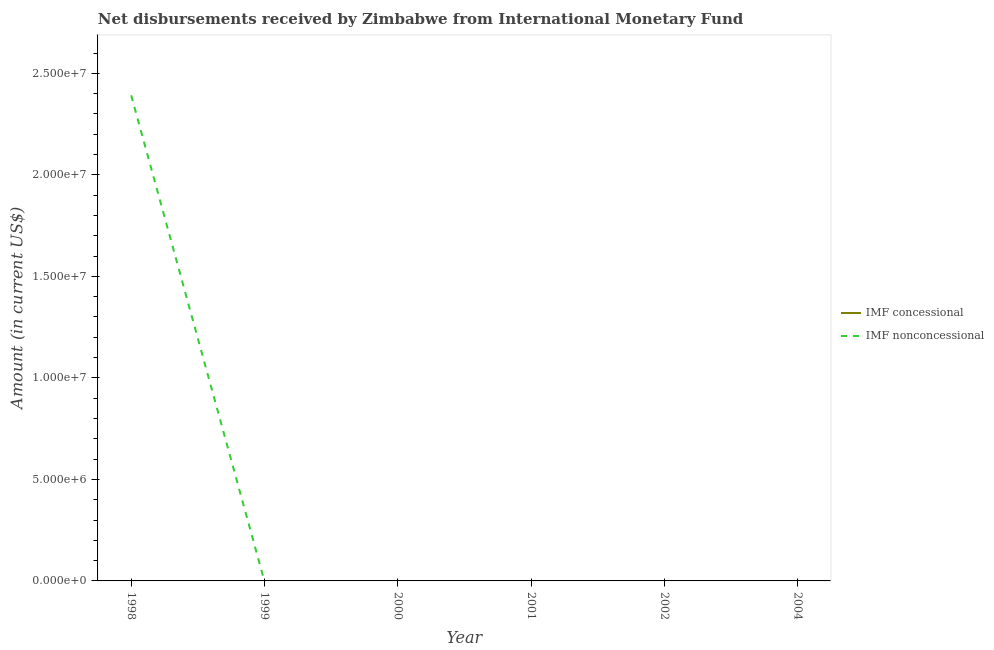Does the line corresponding to net non concessional disbursements from imf intersect with the line corresponding to net concessional disbursements from imf?
Offer a terse response. Yes. Is the number of lines equal to the number of legend labels?
Keep it short and to the point. No. Across all years, what is the maximum net non concessional disbursements from imf?
Provide a short and direct response. 2.39e+07. What is the total net non concessional disbursements from imf in the graph?
Your answer should be very brief. 2.39e+07. What is the difference between the net non concessional disbursements from imf in 1998 and the net concessional disbursements from imf in 1999?
Keep it short and to the point. 2.39e+07. In how many years, is the net concessional disbursements from imf greater than 7000000 US$?
Give a very brief answer. 0. What is the difference between the highest and the lowest net non concessional disbursements from imf?
Give a very brief answer. 2.39e+07. Does the net non concessional disbursements from imf monotonically increase over the years?
Offer a terse response. No. How many years are there in the graph?
Offer a terse response. 6. What is the difference between two consecutive major ticks on the Y-axis?
Your answer should be very brief. 5.00e+06. Are the values on the major ticks of Y-axis written in scientific E-notation?
Give a very brief answer. Yes. Does the graph contain any zero values?
Your response must be concise. Yes. Where does the legend appear in the graph?
Offer a terse response. Center right. What is the title of the graph?
Your response must be concise. Net disbursements received by Zimbabwe from International Monetary Fund. Does "Age 15+" appear as one of the legend labels in the graph?
Your answer should be very brief. No. What is the label or title of the X-axis?
Make the answer very short. Year. What is the Amount (in current US$) in IMF nonconcessional in 1998?
Ensure brevity in your answer.  2.39e+07. What is the Amount (in current US$) of IMF concessional in 1999?
Keep it short and to the point. 0. What is the Amount (in current US$) in IMF nonconcessional in 1999?
Your answer should be very brief. 0. What is the Amount (in current US$) in IMF concessional in 2000?
Make the answer very short. 0. What is the Amount (in current US$) of IMF nonconcessional in 2000?
Your answer should be very brief. 0. What is the Amount (in current US$) of IMF concessional in 2001?
Provide a short and direct response. 0. What is the Amount (in current US$) of IMF concessional in 2002?
Provide a short and direct response. 0. What is the Amount (in current US$) in IMF nonconcessional in 2002?
Make the answer very short. 0. What is the Amount (in current US$) in IMF concessional in 2004?
Provide a short and direct response. 0. Across all years, what is the maximum Amount (in current US$) in IMF nonconcessional?
Your response must be concise. 2.39e+07. Across all years, what is the minimum Amount (in current US$) of IMF nonconcessional?
Ensure brevity in your answer.  0. What is the total Amount (in current US$) in IMF concessional in the graph?
Provide a succinct answer. 0. What is the total Amount (in current US$) in IMF nonconcessional in the graph?
Make the answer very short. 2.39e+07. What is the average Amount (in current US$) in IMF concessional per year?
Keep it short and to the point. 0. What is the average Amount (in current US$) in IMF nonconcessional per year?
Your answer should be very brief. 3.99e+06. What is the difference between the highest and the lowest Amount (in current US$) of IMF nonconcessional?
Provide a short and direct response. 2.39e+07. 